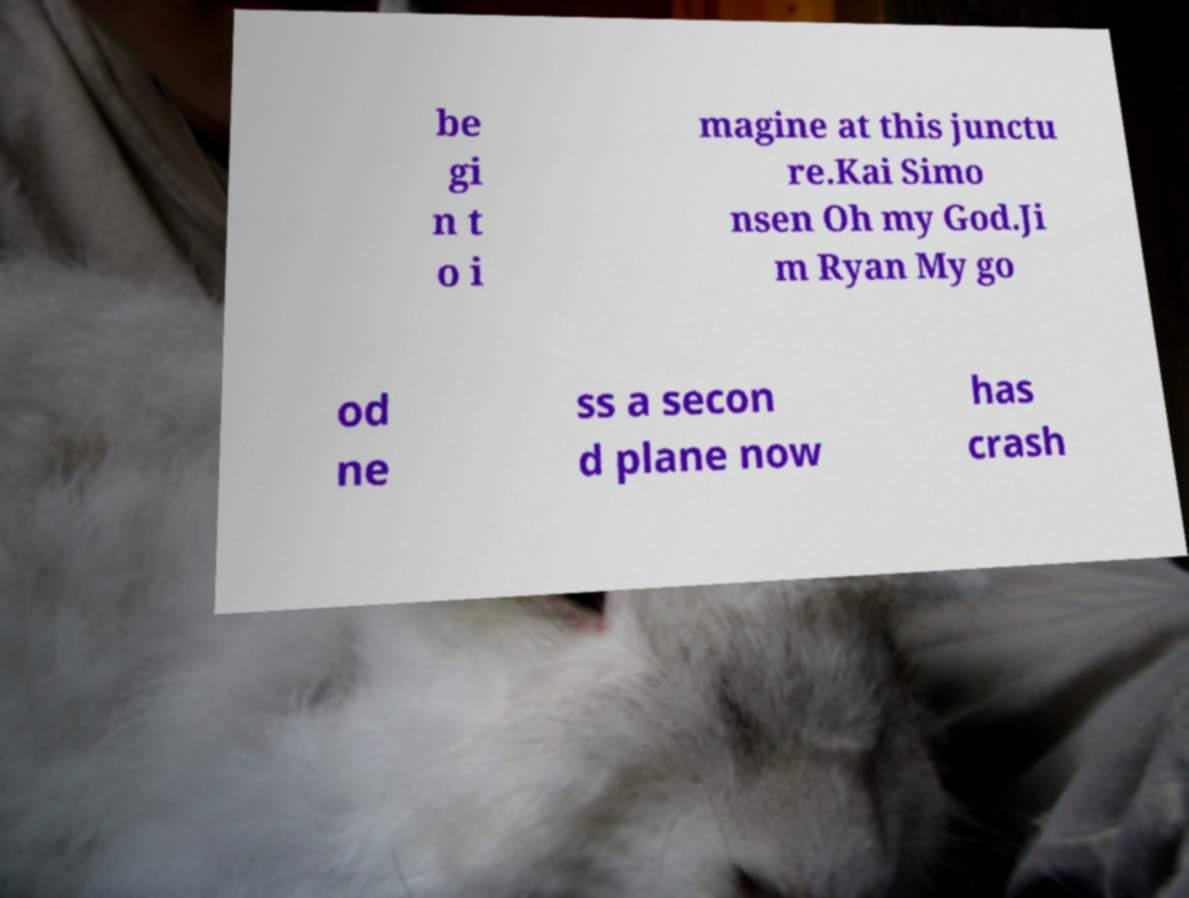I need the written content from this picture converted into text. Can you do that? be gi n t o i magine at this junctu re.Kai Simo nsen Oh my God.Ji m Ryan My go od ne ss a secon d plane now has crash 